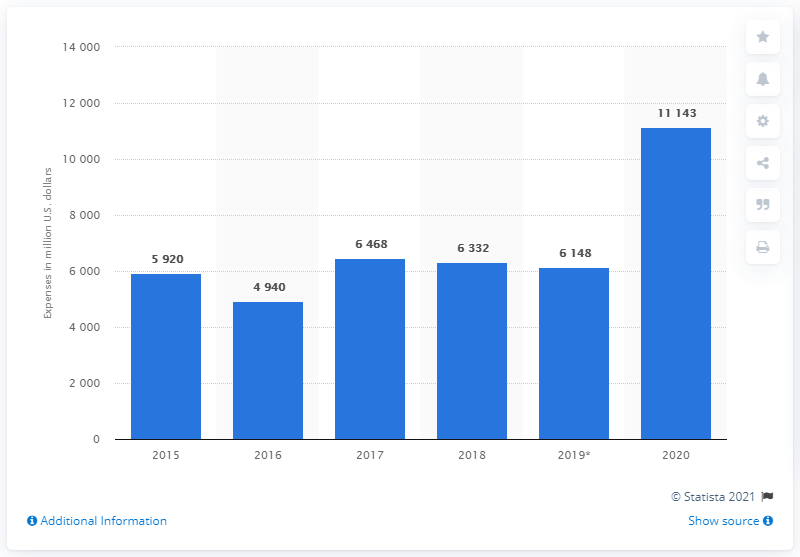Draw attention to some important aspects in this diagram. Bristol-Myers Squibb's R&D spending in 2020 was 11,143. 